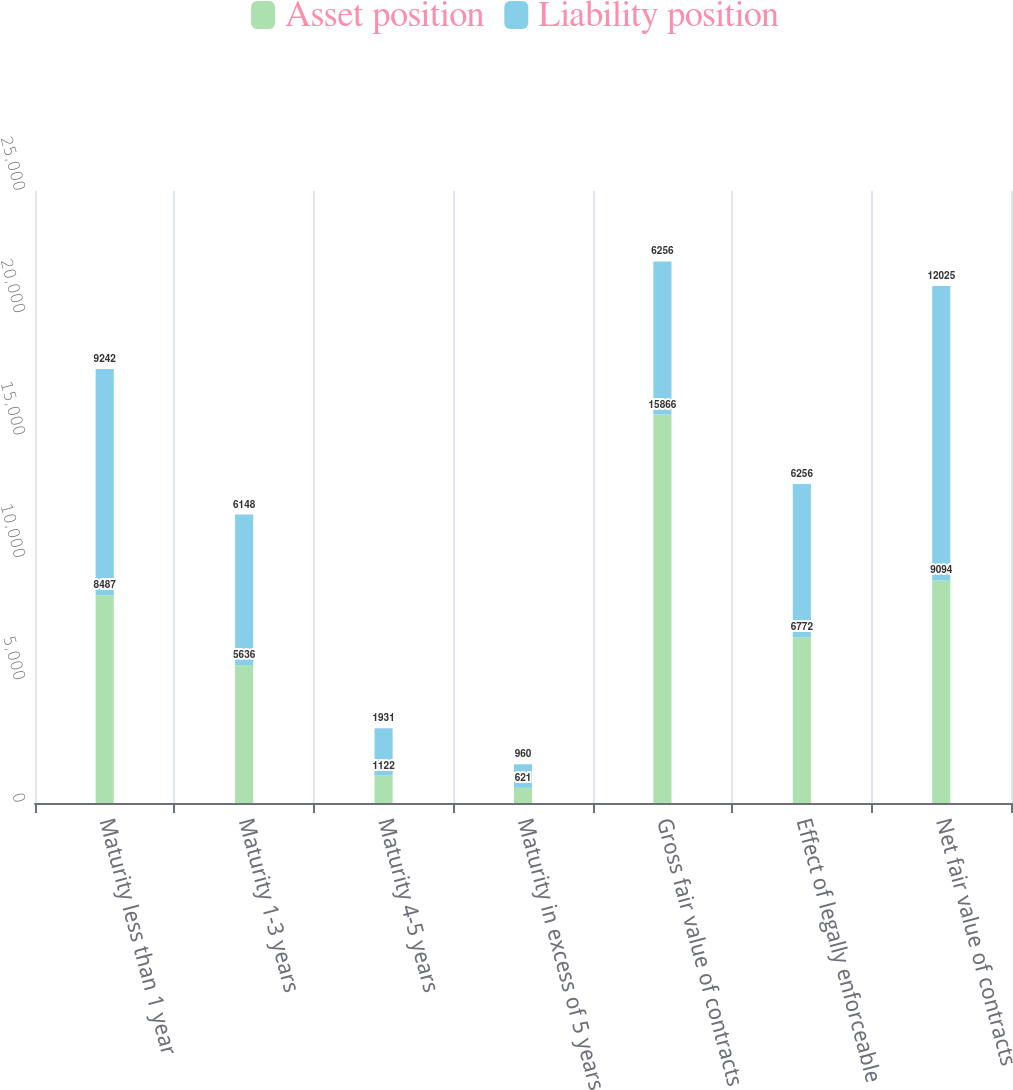Convert chart. <chart><loc_0><loc_0><loc_500><loc_500><stacked_bar_chart><ecel><fcel>Maturity less than 1 year<fcel>Maturity 1-3 years<fcel>Maturity 4-5 years<fcel>Maturity in excess of 5 years<fcel>Gross fair value of contracts<fcel>Effect of legally enforceable<fcel>Net fair value of contracts<nl><fcel>Asset position<fcel>8487<fcel>5636<fcel>1122<fcel>621<fcel>15866<fcel>6772<fcel>9094<nl><fcel>Liability position<fcel>9242<fcel>6148<fcel>1931<fcel>960<fcel>6256<fcel>6256<fcel>12025<nl></chart> 